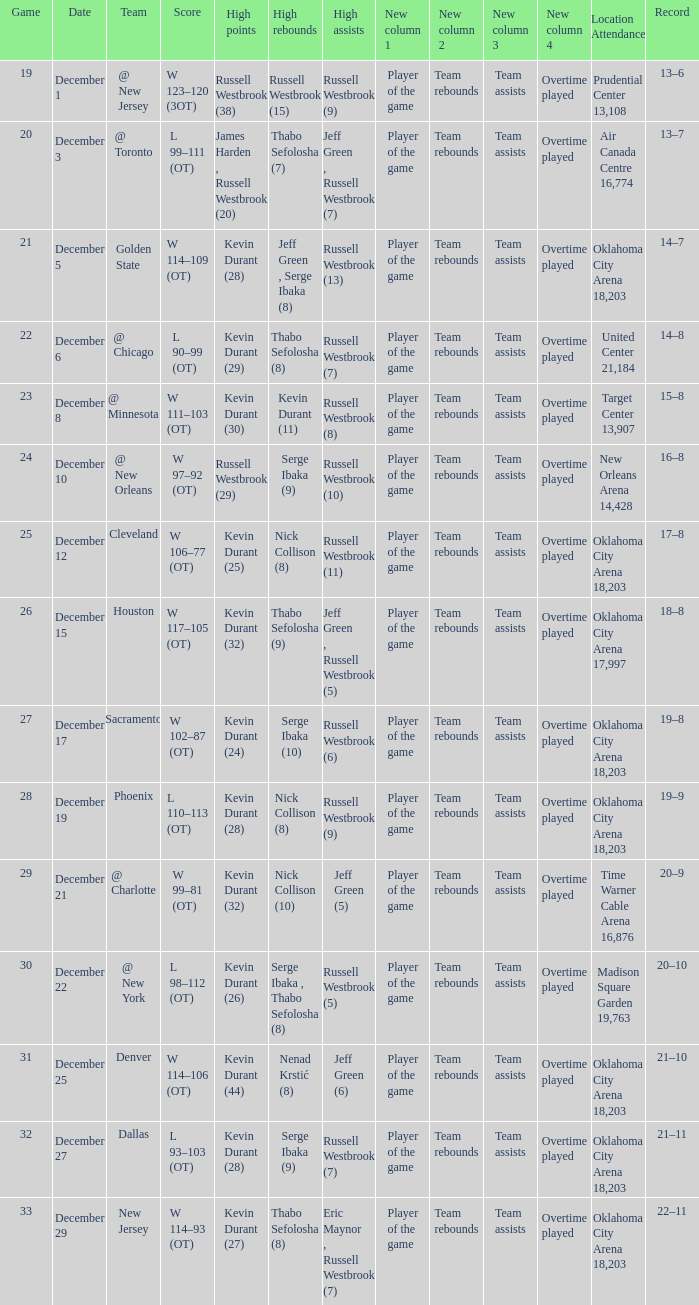Who had the high rebounds record on December 12? Nick Collison (8). 